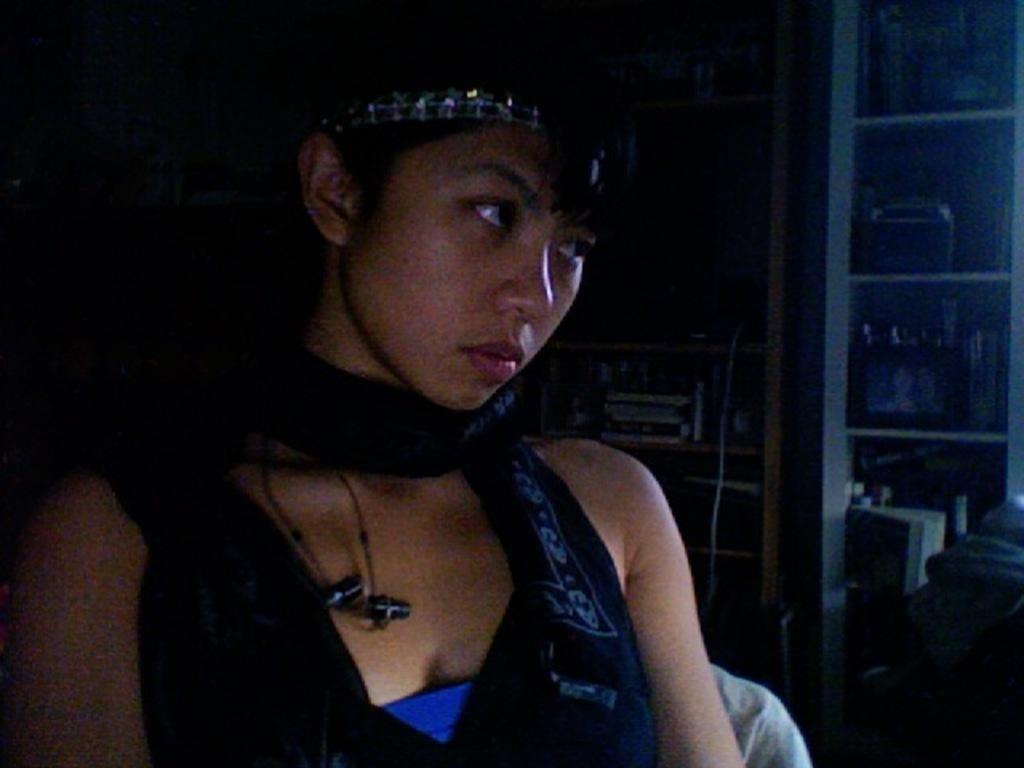What is the primary subject in the image? There is a person sitting in the image. Can you describe the setting or environment in the image? In the background of the image, there are objects placed in racks. What type of plate is sparking in the image? There is no plate or spark present in the image. 